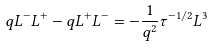Convert formula to latex. <formula><loc_0><loc_0><loc_500><loc_500>q L ^ { - } L ^ { + } - q L ^ { + } L ^ { - } = - \frac { 1 } { q ^ { 2 } } \tau ^ { - 1 / 2 } L ^ { 3 }</formula> 